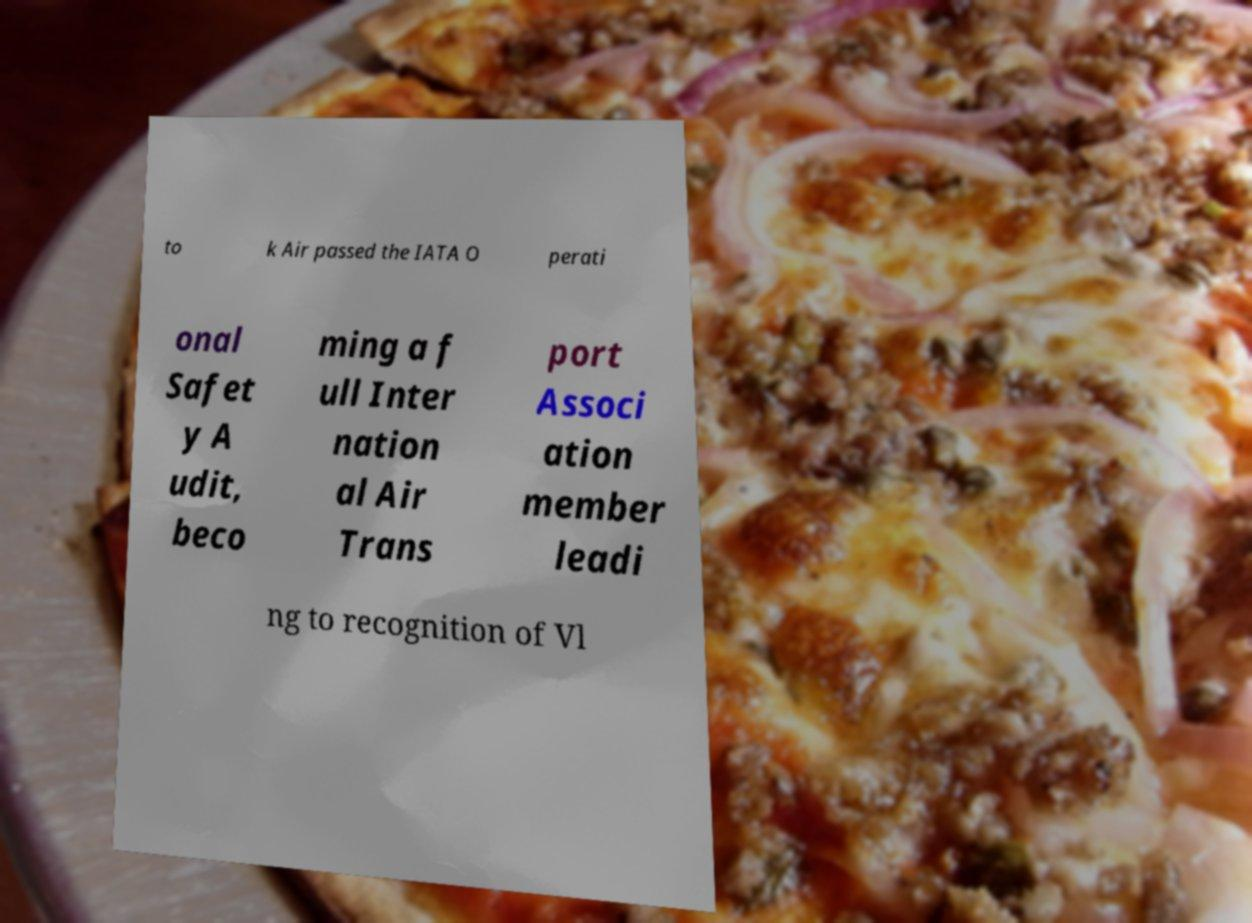For documentation purposes, I need the text within this image transcribed. Could you provide that? to k Air passed the IATA O perati onal Safet y A udit, beco ming a f ull Inter nation al Air Trans port Associ ation member leadi ng to recognition of Vl 